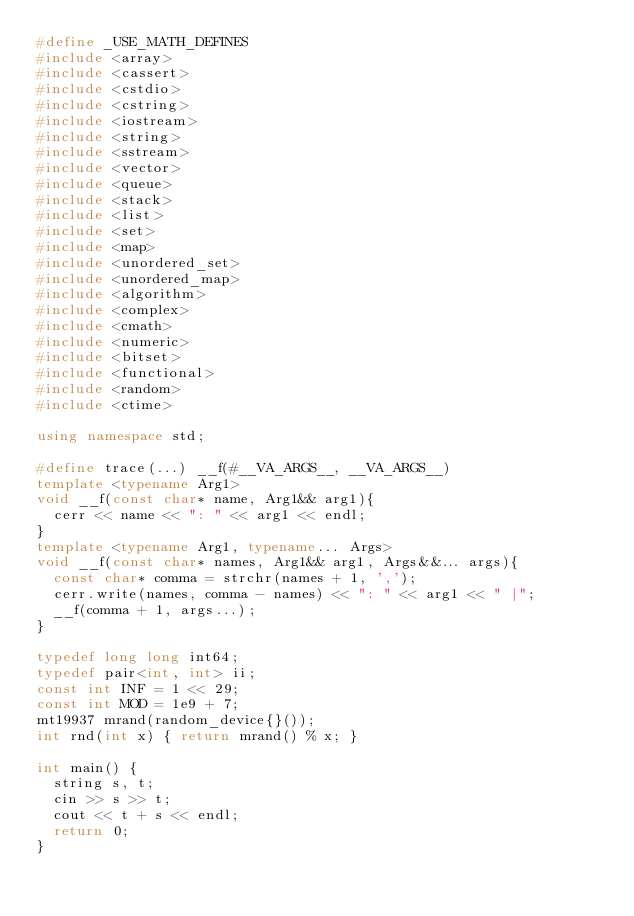Convert code to text. <code><loc_0><loc_0><loc_500><loc_500><_C++_>#define _USE_MATH_DEFINES
#include <array>
#include <cassert>
#include <cstdio>
#include <cstring>
#include <iostream>
#include <string>
#include <sstream>
#include <vector>
#include <queue>
#include <stack>
#include <list>
#include <set>
#include <map>
#include <unordered_set>
#include <unordered_map>
#include <algorithm>
#include <complex>
#include <cmath>
#include <numeric>
#include <bitset>
#include <functional>
#include <random>
#include <ctime>

using namespace std;

#define trace(...) __f(#__VA_ARGS__, __VA_ARGS__)
template <typename Arg1>
void __f(const char* name, Arg1&& arg1){
  cerr << name << ": " << arg1 << endl;
}
template <typename Arg1, typename... Args>
void __f(const char* names, Arg1&& arg1, Args&&... args){
  const char* comma = strchr(names + 1, ',');
  cerr.write(names, comma - names) << ": " << arg1 << " |";
  __f(comma + 1, args...);
}

typedef long long int64;
typedef pair<int, int> ii;
const int INF = 1 << 29;
const int MOD = 1e9 + 7;
mt19937 mrand(random_device{}());
int rnd(int x) { return mrand() % x; }

int main() {
  string s, t;
  cin >> s >> t;
  cout << t + s << endl;
  return 0;
}
</code> 